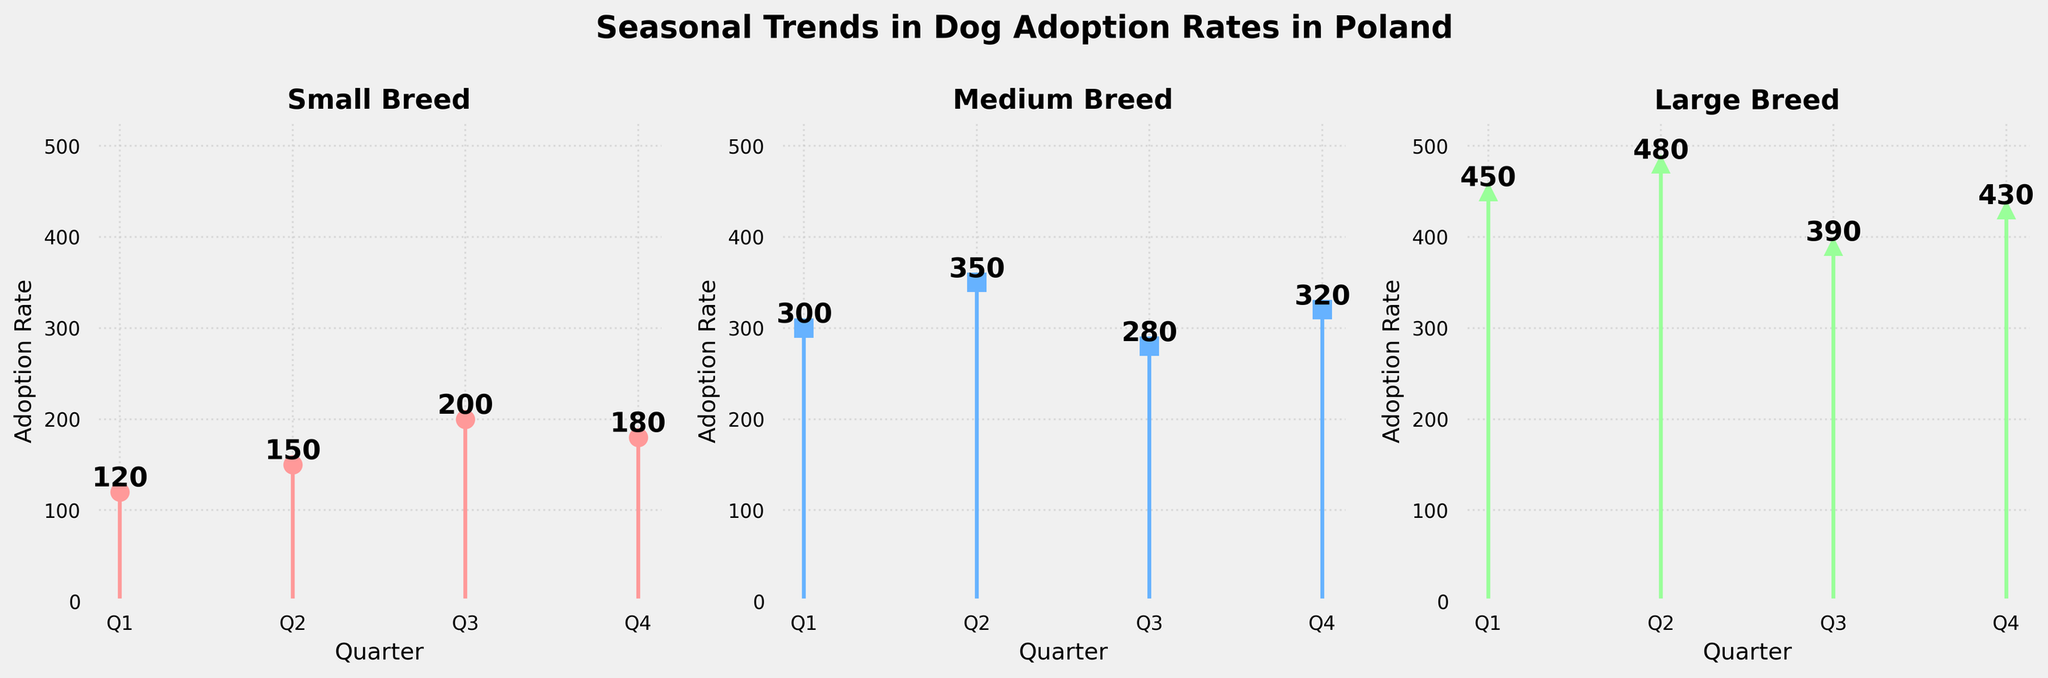What is the title of the figure? The title of the figure is displayed at the top and it reads "Seasonal Trends in Dog Adoption Rates in Poland."
Answer: Seasonal Trends in Dog Adoption Rates in Poland Which breed has the highest adoption rate in Q2? Checking the data points for Q2, we see that the small breed has an adoption rate of 150, the medium breed has 350, and the large breed has 480. The highest adoption rate belongs to the large breed.
Answer: Large breed How many adoption rates are presented for each breed? The figure shows adoption rates for four quarters (Q1, Q2, Q3, Q4) for each breed.
Answer: Four What is the total adoption rate for the small breed across all quarters? Adding up the adoption rates for Q1, Q2, Q3, and Q4 for the small breed: 120 + 150 + 200 + 180 = 650.
Answer: 650 Which quarter shows the highest adoption rate for the small breed? By comparing the adoption rates for all quarters for the small breed (Q1: 120, Q2: 150, Q3: 200, Q4: 180), Q3 has the highest rate.
Answer: Q3 Does the large breed’s adoption rate increase or decrease from Q1 to Q3? Observing the adoption rates from Q1 (450) to Q3 (390) for the large breed shows a decrease.
Answer: Decrease What is the average adoption rate for the medium breed across all quarters? The adoption rates for the medium breed are 300, 350, 280, and 320. Adding these gives 1250, and dividing by 4 quarters gives an average of 1250/4 = 312.5.
Answer: 312.5 Compare the adoption rate trends of the small and large breeds across all quarters. Both small and large breeds increase from Q1 to Q2 (small: 120 to 150, large: 450 to 480). From Q2 to Q3, small breed increases again (150 to 200), but the large breed decreases (480 to 390). Finally, from Q3 to Q4, small breed decreases (200 to 180) while large breed increases (390 to 430).
Answer: The small breed mostly increases in Q1-Q3 and decreases in Q4; the large breed increases in Q1-Q2, decreases in Q3, and increases again in Q4 Which breed's adoption rate shows the least fluctuation across quarters? The adoption rates for each quarter are: Small (120, 150, 200, 180), Medium (300, 350, 280, 320), Large (450, 480, 390, 430). Calculating the range: Small (200-120 = 80), Medium (350-280 = 70), Large (480-390 = 90). Medium breed has the smallest range, indicating the least fluctuation.
Answer: Medium breed 